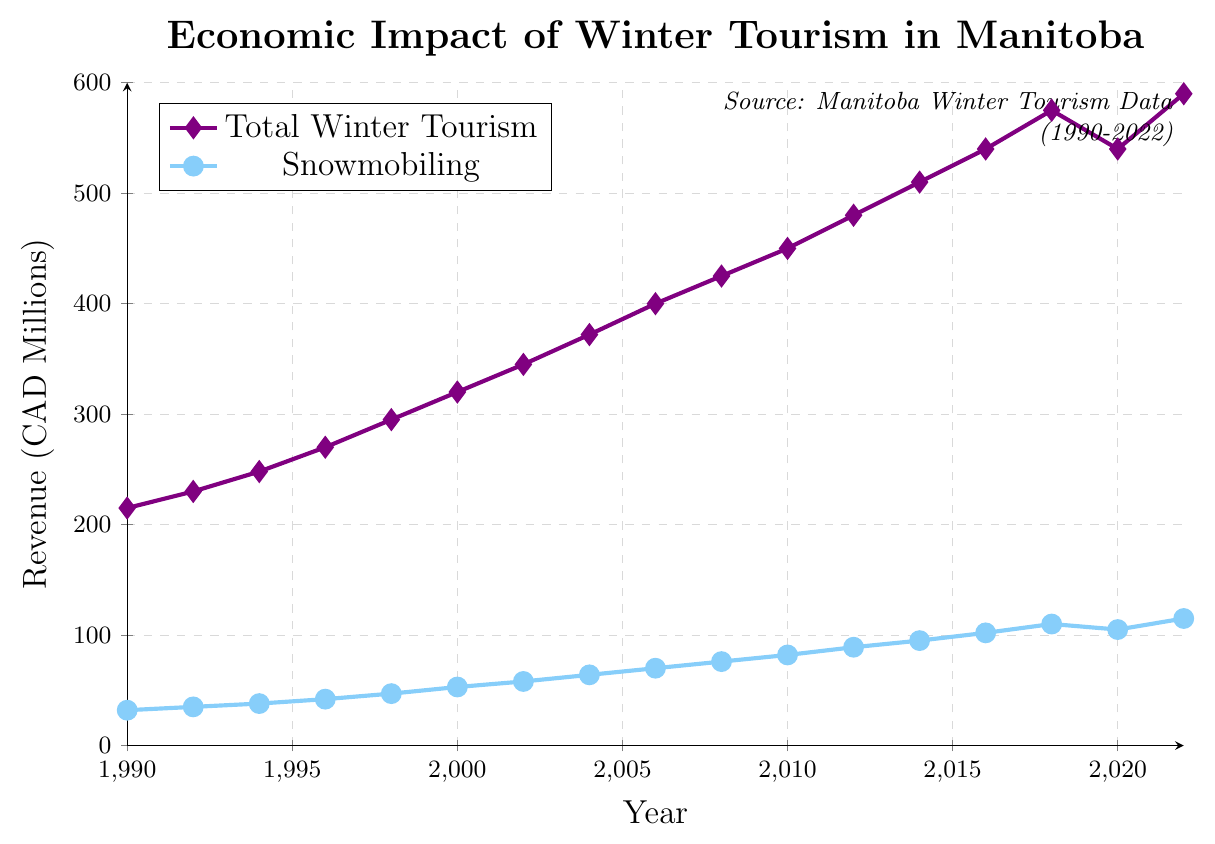What was the total revenue from winter tourism in 1996, and what percentage of that was from snowmobiling? The total revenue in 1996 was 270 million CAD, and the snowmobiling revenue was 42 million CAD. The percentage can be calculated as (42/270) * 100, which equals approximately 15.56%.
Answer: 15.56% How many years did it take for the snowmobiling revenue to grow from 53 million CAD in 2000 to 105 million CAD in 2020? The snowmobiling revenue was 53 million CAD in 2000 and reached 105 million CAD by 2020. This growth happened over a period of 2020 - 2000 = 20 years.
Answer: 20 years Which year saw the highest total winter tourism revenue, and what was the amount? The highest total winter tourism revenue was in 2022, with an amount of 590 million CAD.
Answer: 2022, 590 million CAD How did the total winter tourism revenue change from 2018 to 2020, and what was the difference? In 2018, the total winter tourism revenue was 575 million CAD, and in 2020 it was 540 million CAD. The difference is 575 - 540 = 35 million CAD.
Answer: Decreased by 35 million CAD Compare the growth rate of snowmobiling revenue and total winter tourism revenue from 1990 to 2022. The snowmobiling revenue grew from 32 million CAD in 1990 to 115 million CAD in 2022, while the total winter tourism revenue grew from 215 million CAD in 1990 to 590 million CAD in 2022. The growth rates are calculated as follows: 
   Snowmobiling growth rate = ((115 - 32) / 32) * 100 ≈ 259.38%
   Total winter tourism growth rate = ((590 - 215) / 215) * 100 ≈ 174.42%
Answer: Snowmobiling: 259.38%, Total winter tourism: 174.42% What is the average snowmobiling revenue over the entire period shown? The snowmobiling revenues from each year are: 32, 35, 38, 42, 47, 53, 58, 64, 70, 76, 82, 89, 95, 102, 110, 105, 115. The sum of these values is 1203 million CAD. There are 17 data points, so the average is 1203 / 17 ≈ 70.76 million CAD.
Answer: 70.76 million CAD Identify two years where the increase in snowmobiling revenue was the greatest and by how much it increased. From 1990 to 1992, the increase was 35 - 32 = 3 million CAD. From 1992 to 1994, it was 38 - 35 = 3 million CAD. From 1994 to 1996, it was 42 - 38 = 4 million CAD, etc. The two greatest increases were: 
   2016 to 2018: 110 - 102 = 8 million CAD 
   1998 to 2000: 53 - 47 = 6 million CAD
Answer: 2016 to 2018: 8 million CAD, 1998 to 2000: 6 million CAD What trend can you observe in the total winter tourism revenue during the periods of 2008 to 2012? From 2008 to 2012, the total winter tourism revenue increased consistently every two years: 
   2008: 425 million CAD
   2010: 450 million CAD
   2012: 480 million CAD 
   The trend shows a steady increase in revenue over these years.
Answer: Steady increase 